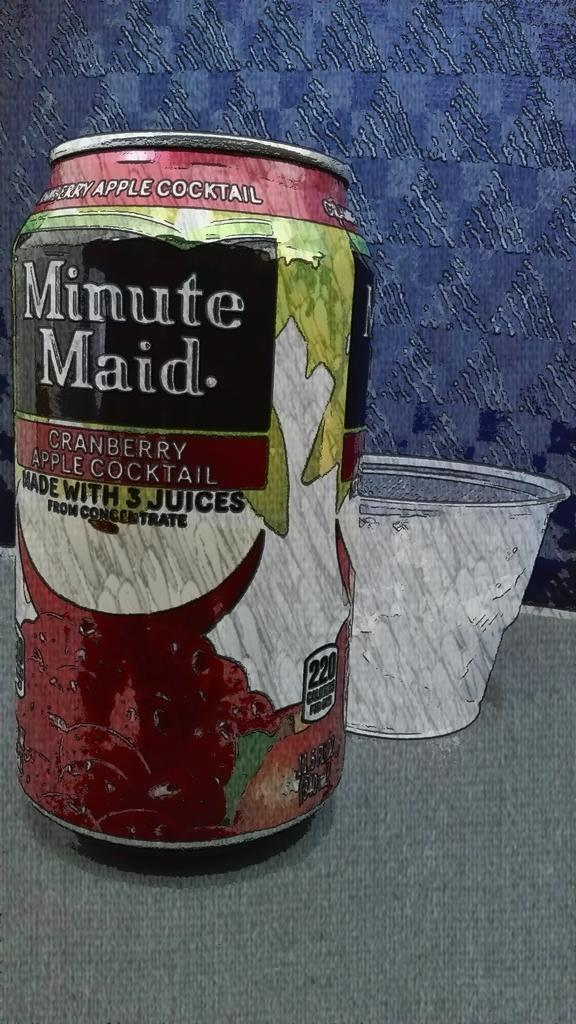<image>
Present a compact description of the photo's key features. a aluminum can of minute maid cranberry apple cocktail 